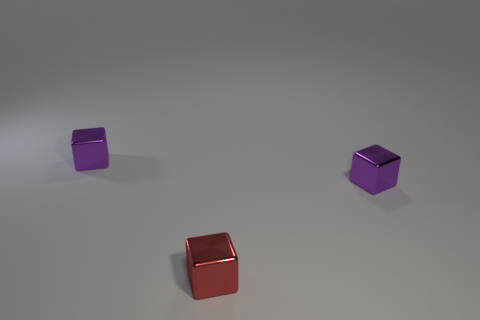Add 1 tiny green rubber cylinders. How many objects exist? 4 Subtract all big green shiny things. Subtract all tiny red blocks. How many objects are left? 2 Add 2 red shiny blocks. How many red shiny blocks are left? 3 Add 1 red objects. How many red objects exist? 2 Subtract 0 blue cylinders. How many objects are left? 3 